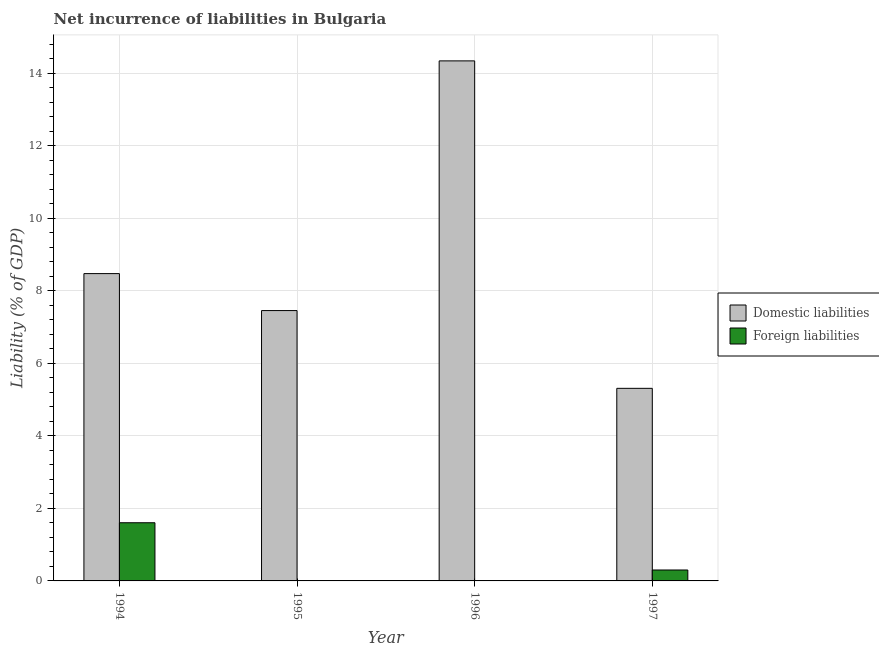Are the number of bars on each tick of the X-axis equal?
Provide a succinct answer. No. How many bars are there on the 4th tick from the left?
Provide a succinct answer. 2. What is the incurrence of domestic liabilities in 1996?
Provide a short and direct response. 14.34. Across all years, what is the maximum incurrence of foreign liabilities?
Offer a terse response. 1.6. Across all years, what is the minimum incurrence of domestic liabilities?
Offer a very short reply. 5.31. In which year was the incurrence of domestic liabilities maximum?
Provide a short and direct response. 1996. What is the total incurrence of foreign liabilities in the graph?
Keep it short and to the point. 1.91. What is the difference between the incurrence of domestic liabilities in 1994 and that in 1996?
Offer a very short reply. -5.87. What is the difference between the incurrence of foreign liabilities in 1995 and the incurrence of domestic liabilities in 1994?
Offer a very short reply. -1.6. What is the average incurrence of domestic liabilities per year?
Ensure brevity in your answer.  8.9. In the year 1994, what is the difference between the incurrence of foreign liabilities and incurrence of domestic liabilities?
Provide a short and direct response. 0. What is the ratio of the incurrence of domestic liabilities in 1996 to that in 1997?
Provide a succinct answer. 2.7. Is the incurrence of domestic liabilities in 1995 less than that in 1997?
Keep it short and to the point. No. Is the difference between the incurrence of domestic liabilities in 1996 and 1997 greater than the difference between the incurrence of foreign liabilities in 1996 and 1997?
Offer a terse response. No. What is the difference between the highest and the second highest incurrence of domestic liabilities?
Your response must be concise. 5.87. What is the difference between the highest and the lowest incurrence of domestic liabilities?
Give a very brief answer. 9.03. Is the sum of the incurrence of domestic liabilities in 1994 and 1996 greater than the maximum incurrence of foreign liabilities across all years?
Make the answer very short. Yes. How many bars are there?
Provide a short and direct response. 6. Are all the bars in the graph horizontal?
Provide a short and direct response. No. How many years are there in the graph?
Keep it short and to the point. 4. What is the difference between two consecutive major ticks on the Y-axis?
Provide a short and direct response. 2. Does the graph contain any zero values?
Provide a short and direct response. Yes. Does the graph contain grids?
Provide a succinct answer. Yes. Where does the legend appear in the graph?
Your answer should be compact. Center right. How many legend labels are there?
Offer a very short reply. 2. How are the legend labels stacked?
Offer a very short reply. Vertical. What is the title of the graph?
Your response must be concise. Net incurrence of liabilities in Bulgaria. Does "Start a business" appear as one of the legend labels in the graph?
Offer a terse response. No. What is the label or title of the X-axis?
Provide a succinct answer. Year. What is the label or title of the Y-axis?
Provide a short and direct response. Liability (% of GDP). What is the Liability (% of GDP) of Domestic liabilities in 1994?
Offer a terse response. 8.48. What is the Liability (% of GDP) of Foreign liabilities in 1994?
Give a very brief answer. 1.6. What is the Liability (% of GDP) in Domestic liabilities in 1995?
Give a very brief answer. 7.46. What is the Liability (% of GDP) in Domestic liabilities in 1996?
Provide a succinct answer. 14.34. What is the Liability (% of GDP) in Foreign liabilities in 1996?
Keep it short and to the point. 0. What is the Liability (% of GDP) of Domestic liabilities in 1997?
Provide a succinct answer. 5.31. What is the Liability (% of GDP) of Foreign liabilities in 1997?
Your answer should be very brief. 0.3. Across all years, what is the maximum Liability (% of GDP) of Domestic liabilities?
Make the answer very short. 14.34. Across all years, what is the maximum Liability (% of GDP) in Foreign liabilities?
Give a very brief answer. 1.6. Across all years, what is the minimum Liability (% of GDP) of Domestic liabilities?
Offer a very short reply. 5.31. What is the total Liability (% of GDP) in Domestic liabilities in the graph?
Make the answer very short. 35.59. What is the total Liability (% of GDP) in Foreign liabilities in the graph?
Keep it short and to the point. 1.91. What is the difference between the Liability (% of GDP) of Domestic liabilities in 1994 and that in 1995?
Your answer should be compact. 1.02. What is the difference between the Liability (% of GDP) in Domestic liabilities in 1994 and that in 1996?
Offer a terse response. -5.87. What is the difference between the Liability (% of GDP) in Domestic liabilities in 1994 and that in 1997?
Give a very brief answer. 3.16. What is the difference between the Liability (% of GDP) of Foreign liabilities in 1994 and that in 1997?
Give a very brief answer. 1.3. What is the difference between the Liability (% of GDP) of Domestic liabilities in 1995 and that in 1996?
Offer a terse response. -6.89. What is the difference between the Liability (% of GDP) in Domestic liabilities in 1995 and that in 1997?
Your response must be concise. 2.14. What is the difference between the Liability (% of GDP) in Domestic liabilities in 1996 and that in 1997?
Offer a terse response. 9.03. What is the difference between the Liability (% of GDP) of Domestic liabilities in 1994 and the Liability (% of GDP) of Foreign liabilities in 1997?
Offer a very short reply. 8.17. What is the difference between the Liability (% of GDP) of Domestic liabilities in 1995 and the Liability (% of GDP) of Foreign liabilities in 1997?
Your answer should be very brief. 7.15. What is the difference between the Liability (% of GDP) in Domestic liabilities in 1996 and the Liability (% of GDP) in Foreign liabilities in 1997?
Your response must be concise. 14.04. What is the average Liability (% of GDP) of Domestic liabilities per year?
Give a very brief answer. 8.9. What is the average Liability (% of GDP) of Foreign liabilities per year?
Ensure brevity in your answer.  0.48. In the year 1994, what is the difference between the Liability (% of GDP) in Domestic liabilities and Liability (% of GDP) in Foreign liabilities?
Offer a very short reply. 6.87. In the year 1997, what is the difference between the Liability (% of GDP) in Domestic liabilities and Liability (% of GDP) in Foreign liabilities?
Make the answer very short. 5.01. What is the ratio of the Liability (% of GDP) in Domestic liabilities in 1994 to that in 1995?
Make the answer very short. 1.14. What is the ratio of the Liability (% of GDP) of Domestic liabilities in 1994 to that in 1996?
Keep it short and to the point. 0.59. What is the ratio of the Liability (% of GDP) in Domestic liabilities in 1994 to that in 1997?
Offer a terse response. 1.6. What is the ratio of the Liability (% of GDP) of Foreign liabilities in 1994 to that in 1997?
Provide a succinct answer. 5.32. What is the ratio of the Liability (% of GDP) of Domestic liabilities in 1995 to that in 1996?
Offer a very short reply. 0.52. What is the ratio of the Liability (% of GDP) of Domestic liabilities in 1995 to that in 1997?
Provide a succinct answer. 1.4. What is the ratio of the Liability (% of GDP) of Domestic liabilities in 1996 to that in 1997?
Your answer should be compact. 2.7. What is the difference between the highest and the second highest Liability (% of GDP) of Domestic liabilities?
Ensure brevity in your answer.  5.87. What is the difference between the highest and the lowest Liability (% of GDP) in Domestic liabilities?
Make the answer very short. 9.03. What is the difference between the highest and the lowest Liability (% of GDP) of Foreign liabilities?
Offer a very short reply. 1.6. 